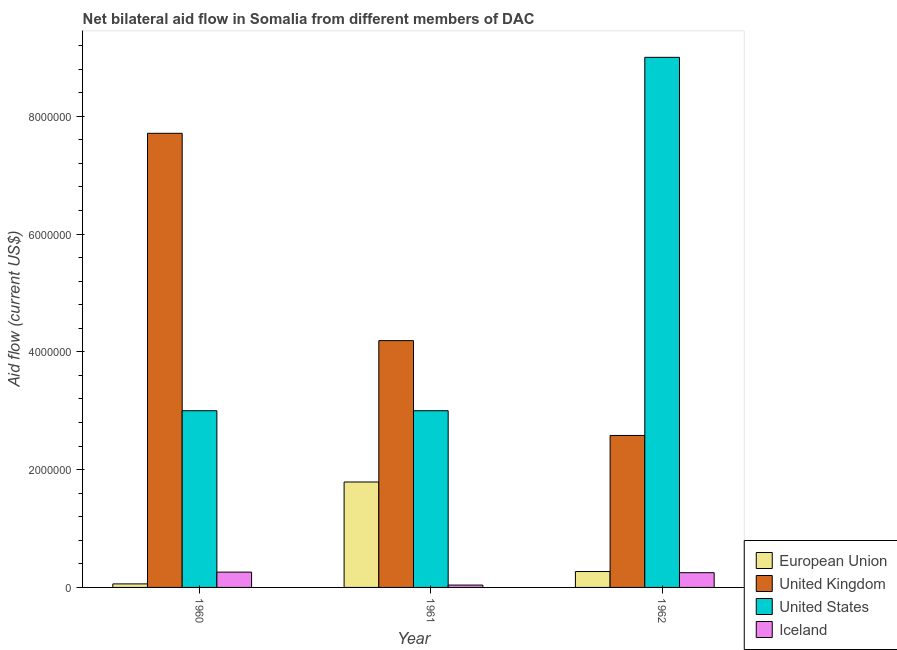How many groups of bars are there?
Offer a terse response. 3. Are the number of bars on each tick of the X-axis equal?
Offer a very short reply. Yes. How many bars are there on the 2nd tick from the left?
Your response must be concise. 4. How many bars are there on the 1st tick from the right?
Your response must be concise. 4. What is the label of the 1st group of bars from the left?
Give a very brief answer. 1960. In how many cases, is the number of bars for a given year not equal to the number of legend labels?
Your response must be concise. 0. What is the amount of aid given by iceland in 1962?
Offer a very short reply. 2.50e+05. Across all years, what is the maximum amount of aid given by uk?
Keep it short and to the point. 7.71e+06. Across all years, what is the minimum amount of aid given by uk?
Give a very brief answer. 2.58e+06. In which year was the amount of aid given by uk maximum?
Your response must be concise. 1960. In which year was the amount of aid given by us minimum?
Your answer should be compact. 1960. What is the total amount of aid given by us in the graph?
Your response must be concise. 1.50e+07. What is the difference between the amount of aid given by eu in 1961 and that in 1962?
Provide a succinct answer. 1.52e+06. What is the difference between the amount of aid given by eu in 1960 and the amount of aid given by iceland in 1961?
Your answer should be compact. -1.73e+06. What is the average amount of aid given by eu per year?
Make the answer very short. 7.07e+05. In how many years, is the amount of aid given by us greater than 5600000 US$?
Provide a short and direct response. 1. What is the ratio of the amount of aid given by uk in 1960 to that in 1961?
Offer a very short reply. 1.84. What is the difference between the highest and the second highest amount of aid given by us?
Your answer should be compact. 6.00e+06. What is the difference between the highest and the lowest amount of aid given by uk?
Ensure brevity in your answer.  5.13e+06. Is the sum of the amount of aid given by us in 1960 and 1962 greater than the maximum amount of aid given by eu across all years?
Your response must be concise. Yes. What does the 3rd bar from the left in 1961 represents?
Offer a very short reply. United States. What does the 3rd bar from the right in 1961 represents?
Give a very brief answer. United Kingdom. Is it the case that in every year, the sum of the amount of aid given by eu and amount of aid given by uk is greater than the amount of aid given by us?
Give a very brief answer. No. How many bars are there?
Give a very brief answer. 12. How many years are there in the graph?
Ensure brevity in your answer.  3. What is the difference between two consecutive major ticks on the Y-axis?
Your answer should be very brief. 2.00e+06. Are the values on the major ticks of Y-axis written in scientific E-notation?
Your response must be concise. No. Does the graph contain any zero values?
Keep it short and to the point. No. Where does the legend appear in the graph?
Your answer should be compact. Bottom right. How many legend labels are there?
Ensure brevity in your answer.  4. How are the legend labels stacked?
Provide a succinct answer. Vertical. What is the title of the graph?
Provide a succinct answer. Net bilateral aid flow in Somalia from different members of DAC. What is the Aid flow (current US$) of United Kingdom in 1960?
Offer a terse response. 7.71e+06. What is the Aid flow (current US$) in European Union in 1961?
Your answer should be very brief. 1.79e+06. What is the Aid flow (current US$) in United Kingdom in 1961?
Your answer should be very brief. 4.19e+06. What is the Aid flow (current US$) of United States in 1961?
Provide a short and direct response. 3.00e+06. What is the Aid flow (current US$) in United Kingdom in 1962?
Your answer should be compact. 2.58e+06. What is the Aid flow (current US$) in United States in 1962?
Provide a short and direct response. 9.00e+06. Across all years, what is the maximum Aid flow (current US$) in European Union?
Your answer should be compact. 1.79e+06. Across all years, what is the maximum Aid flow (current US$) in United Kingdom?
Ensure brevity in your answer.  7.71e+06. Across all years, what is the maximum Aid flow (current US$) of United States?
Your answer should be very brief. 9.00e+06. Across all years, what is the maximum Aid flow (current US$) in Iceland?
Ensure brevity in your answer.  2.60e+05. Across all years, what is the minimum Aid flow (current US$) in United Kingdom?
Your response must be concise. 2.58e+06. What is the total Aid flow (current US$) in European Union in the graph?
Provide a succinct answer. 2.12e+06. What is the total Aid flow (current US$) in United Kingdom in the graph?
Your answer should be very brief. 1.45e+07. What is the total Aid flow (current US$) in United States in the graph?
Make the answer very short. 1.50e+07. What is the difference between the Aid flow (current US$) in European Union in 1960 and that in 1961?
Offer a terse response. -1.73e+06. What is the difference between the Aid flow (current US$) of United Kingdom in 1960 and that in 1961?
Give a very brief answer. 3.52e+06. What is the difference between the Aid flow (current US$) of United States in 1960 and that in 1961?
Your response must be concise. 0. What is the difference between the Aid flow (current US$) in United Kingdom in 1960 and that in 1962?
Make the answer very short. 5.13e+06. What is the difference between the Aid flow (current US$) in United States in 1960 and that in 1962?
Make the answer very short. -6.00e+06. What is the difference between the Aid flow (current US$) of European Union in 1961 and that in 1962?
Offer a very short reply. 1.52e+06. What is the difference between the Aid flow (current US$) of United Kingdom in 1961 and that in 1962?
Your response must be concise. 1.61e+06. What is the difference between the Aid flow (current US$) in United States in 1961 and that in 1962?
Ensure brevity in your answer.  -6.00e+06. What is the difference between the Aid flow (current US$) in Iceland in 1961 and that in 1962?
Keep it short and to the point. -2.10e+05. What is the difference between the Aid flow (current US$) in European Union in 1960 and the Aid flow (current US$) in United Kingdom in 1961?
Ensure brevity in your answer.  -4.13e+06. What is the difference between the Aid flow (current US$) of European Union in 1960 and the Aid flow (current US$) of United States in 1961?
Offer a terse response. -2.94e+06. What is the difference between the Aid flow (current US$) of United Kingdom in 1960 and the Aid flow (current US$) of United States in 1961?
Keep it short and to the point. 4.71e+06. What is the difference between the Aid flow (current US$) of United Kingdom in 1960 and the Aid flow (current US$) of Iceland in 1961?
Give a very brief answer. 7.67e+06. What is the difference between the Aid flow (current US$) in United States in 1960 and the Aid flow (current US$) in Iceland in 1961?
Make the answer very short. 2.96e+06. What is the difference between the Aid flow (current US$) in European Union in 1960 and the Aid flow (current US$) in United Kingdom in 1962?
Provide a succinct answer. -2.52e+06. What is the difference between the Aid flow (current US$) of European Union in 1960 and the Aid flow (current US$) of United States in 1962?
Your answer should be very brief. -8.94e+06. What is the difference between the Aid flow (current US$) of European Union in 1960 and the Aid flow (current US$) of Iceland in 1962?
Ensure brevity in your answer.  -1.90e+05. What is the difference between the Aid flow (current US$) of United Kingdom in 1960 and the Aid flow (current US$) of United States in 1962?
Make the answer very short. -1.29e+06. What is the difference between the Aid flow (current US$) in United Kingdom in 1960 and the Aid flow (current US$) in Iceland in 1962?
Your answer should be compact. 7.46e+06. What is the difference between the Aid flow (current US$) of United States in 1960 and the Aid flow (current US$) of Iceland in 1962?
Make the answer very short. 2.75e+06. What is the difference between the Aid flow (current US$) in European Union in 1961 and the Aid flow (current US$) in United Kingdom in 1962?
Give a very brief answer. -7.90e+05. What is the difference between the Aid flow (current US$) in European Union in 1961 and the Aid flow (current US$) in United States in 1962?
Give a very brief answer. -7.21e+06. What is the difference between the Aid flow (current US$) in European Union in 1961 and the Aid flow (current US$) in Iceland in 1962?
Ensure brevity in your answer.  1.54e+06. What is the difference between the Aid flow (current US$) in United Kingdom in 1961 and the Aid flow (current US$) in United States in 1962?
Offer a very short reply. -4.81e+06. What is the difference between the Aid flow (current US$) of United Kingdom in 1961 and the Aid flow (current US$) of Iceland in 1962?
Give a very brief answer. 3.94e+06. What is the difference between the Aid flow (current US$) of United States in 1961 and the Aid flow (current US$) of Iceland in 1962?
Ensure brevity in your answer.  2.75e+06. What is the average Aid flow (current US$) in European Union per year?
Provide a short and direct response. 7.07e+05. What is the average Aid flow (current US$) in United Kingdom per year?
Ensure brevity in your answer.  4.83e+06. What is the average Aid flow (current US$) in United States per year?
Your response must be concise. 5.00e+06. What is the average Aid flow (current US$) in Iceland per year?
Provide a succinct answer. 1.83e+05. In the year 1960, what is the difference between the Aid flow (current US$) of European Union and Aid flow (current US$) of United Kingdom?
Offer a terse response. -7.65e+06. In the year 1960, what is the difference between the Aid flow (current US$) of European Union and Aid flow (current US$) of United States?
Provide a short and direct response. -2.94e+06. In the year 1960, what is the difference between the Aid flow (current US$) of European Union and Aid flow (current US$) of Iceland?
Make the answer very short. -2.00e+05. In the year 1960, what is the difference between the Aid flow (current US$) of United Kingdom and Aid flow (current US$) of United States?
Your response must be concise. 4.71e+06. In the year 1960, what is the difference between the Aid flow (current US$) of United Kingdom and Aid flow (current US$) of Iceland?
Make the answer very short. 7.45e+06. In the year 1960, what is the difference between the Aid flow (current US$) in United States and Aid flow (current US$) in Iceland?
Provide a short and direct response. 2.74e+06. In the year 1961, what is the difference between the Aid flow (current US$) of European Union and Aid flow (current US$) of United Kingdom?
Keep it short and to the point. -2.40e+06. In the year 1961, what is the difference between the Aid flow (current US$) of European Union and Aid flow (current US$) of United States?
Ensure brevity in your answer.  -1.21e+06. In the year 1961, what is the difference between the Aid flow (current US$) of European Union and Aid flow (current US$) of Iceland?
Provide a succinct answer. 1.75e+06. In the year 1961, what is the difference between the Aid flow (current US$) in United Kingdom and Aid flow (current US$) in United States?
Give a very brief answer. 1.19e+06. In the year 1961, what is the difference between the Aid flow (current US$) in United Kingdom and Aid flow (current US$) in Iceland?
Keep it short and to the point. 4.15e+06. In the year 1961, what is the difference between the Aid flow (current US$) of United States and Aid flow (current US$) of Iceland?
Your answer should be compact. 2.96e+06. In the year 1962, what is the difference between the Aid flow (current US$) of European Union and Aid flow (current US$) of United Kingdom?
Keep it short and to the point. -2.31e+06. In the year 1962, what is the difference between the Aid flow (current US$) of European Union and Aid flow (current US$) of United States?
Your answer should be compact. -8.73e+06. In the year 1962, what is the difference between the Aid flow (current US$) in European Union and Aid flow (current US$) in Iceland?
Your answer should be compact. 2.00e+04. In the year 1962, what is the difference between the Aid flow (current US$) in United Kingdom and Aid flow (current US$) in United States?
Provide a short and direct response. -6.42e+06. In the year 1962, what is the difference between the Aid flow (current US$) in United Kingdom and Aid flow (current US$) in Iceland?
Ensure brevity in your answer.  2.33e+06. In the year 1962, what is the difference between the Aid flow (current US$) of United States and Aid flow (current US$) of Iceland?
Your response must be concise. 8.75e+06. What is the ratio of the Aid flow (current US$) in European Union in 1960 to that in 1961?
Your response must be concise. 0.03. What is the ratio of the Aid flow (current US$) of United Kingdom in 1960 to that in 1961?
Provide a short and direct response. 1.84. What is the ratio of the Aid flow (current US$) of Iceland in 1960 to that in 1961?
Give a very brief answer. 6.5. What is the ratio of the Aid flow (current US$) of European Union in 1960 to that in 1962?
Provide a succinct answer. 0.22. What is the ratio of the Aid flow (current US$) of United Kingdom in 1960 to that in 1962?
Your answer should be very brief. 2.99. What is the ratio of the Aid flow (current US$) in European Union in 1961 to that in 1962?
Your answer should be very brief. 6.63. What is the ratio of the Aid flow (current US$) in United Kingdom in 1961 to that in 1962?
Your answer should be very brief. 1.62. What is the ratio of the Aid flow (current US$) of United States in 1961 to that in 1962?
Give a very brief answer. 0.33. What is the ratio of the Aid flow (current US$) of Iceland in 1961 to that in 1962?
Provide a short and direct response. 0.16. What is the difference between the highest and the second highest Aid flow (current US$) of European Union?
Offer a terse response. 1.52e+06. What is the difference between the highest and the second highest Aid flow (current US$) in United Kingdom?
Your answer should be very brief. 3.52e+06. What is the difference between the highest and the second highest Aid flow (current US$) of United States?
Provide a short and direct response. 6.00e+06. What is the difference between the highest and the lowest Aid flow (current US$) in European Union?
Your response must be concise. 1.73e+06. What is the difference between the highest and the lowest Aid flow (current US$) of United Kingdom?
Keep it short and to the point. 5.13e+06. What is the difference between the highest and the lowest Aid flow (current US$) of Iceland?
Offer a terse response. 2.20e+05. 